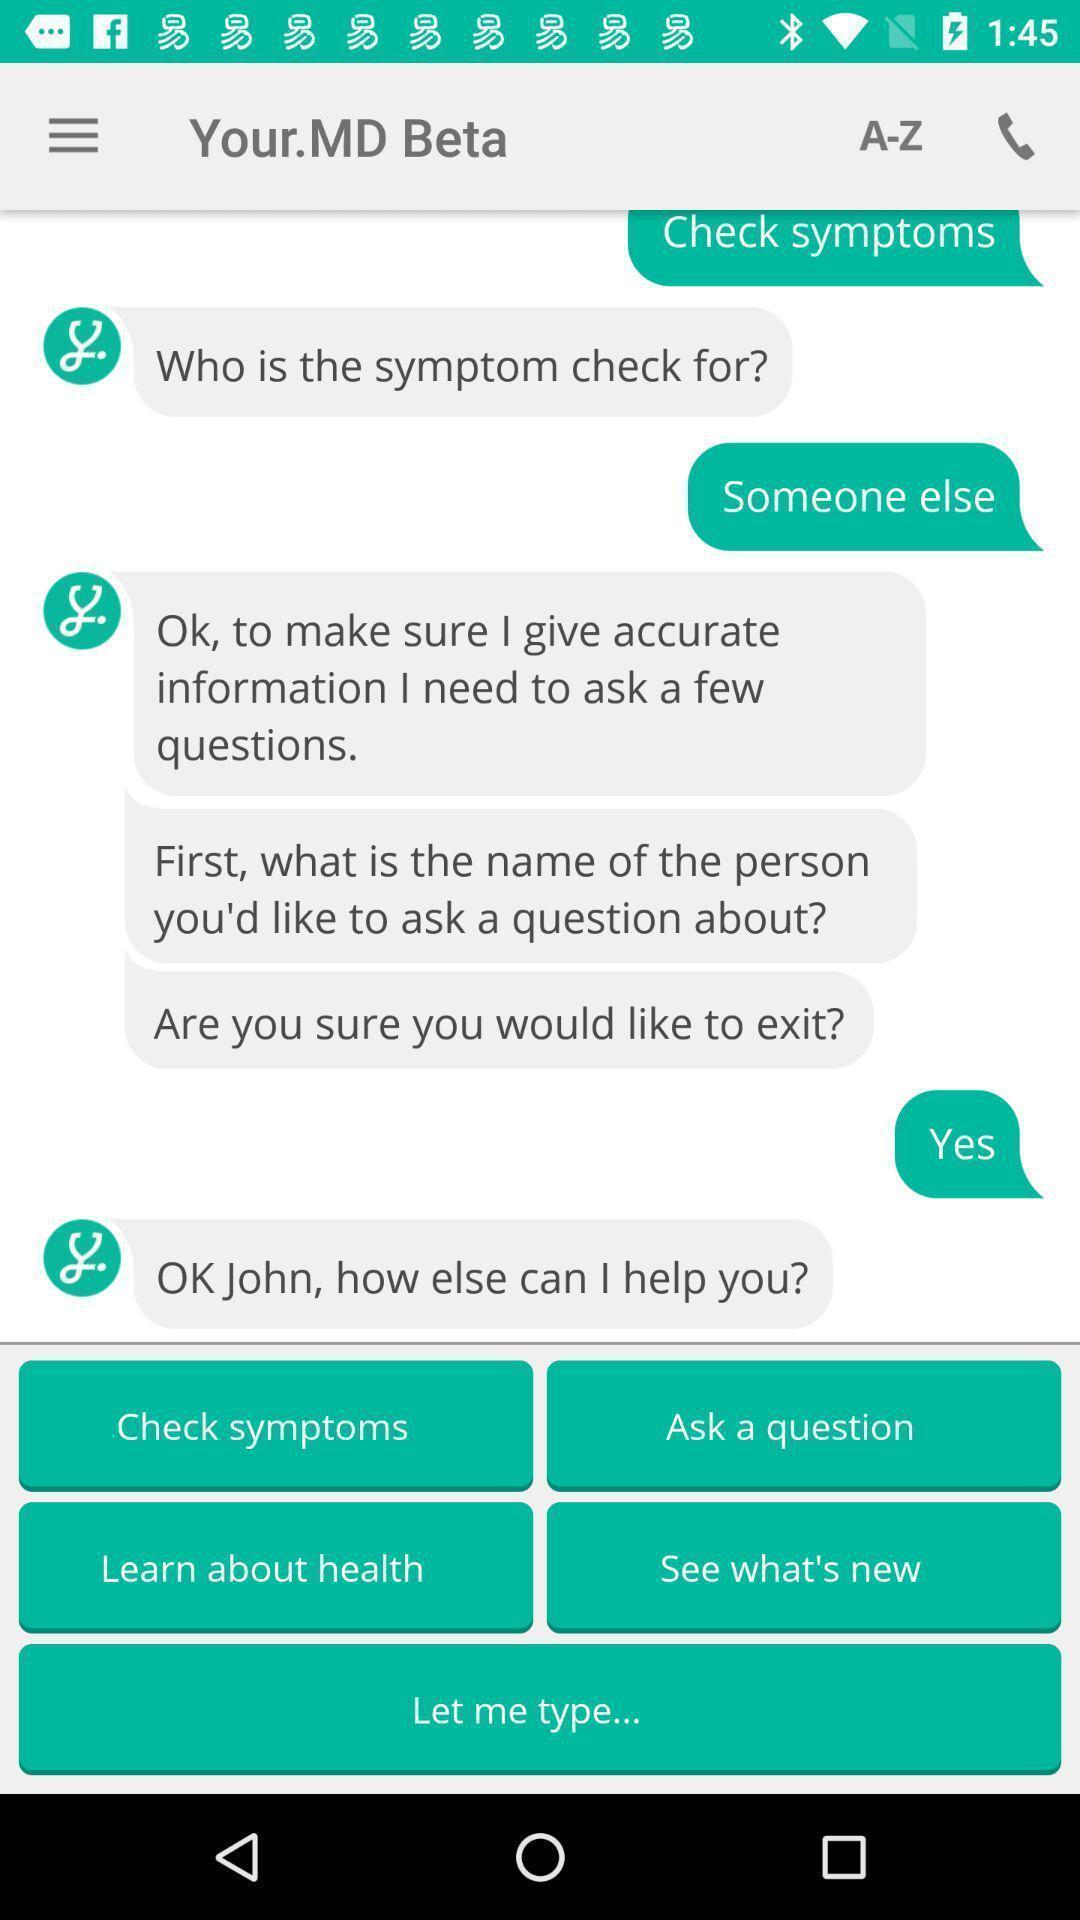Explain what's happening in this screen capture. Page displaying the messaging app. 